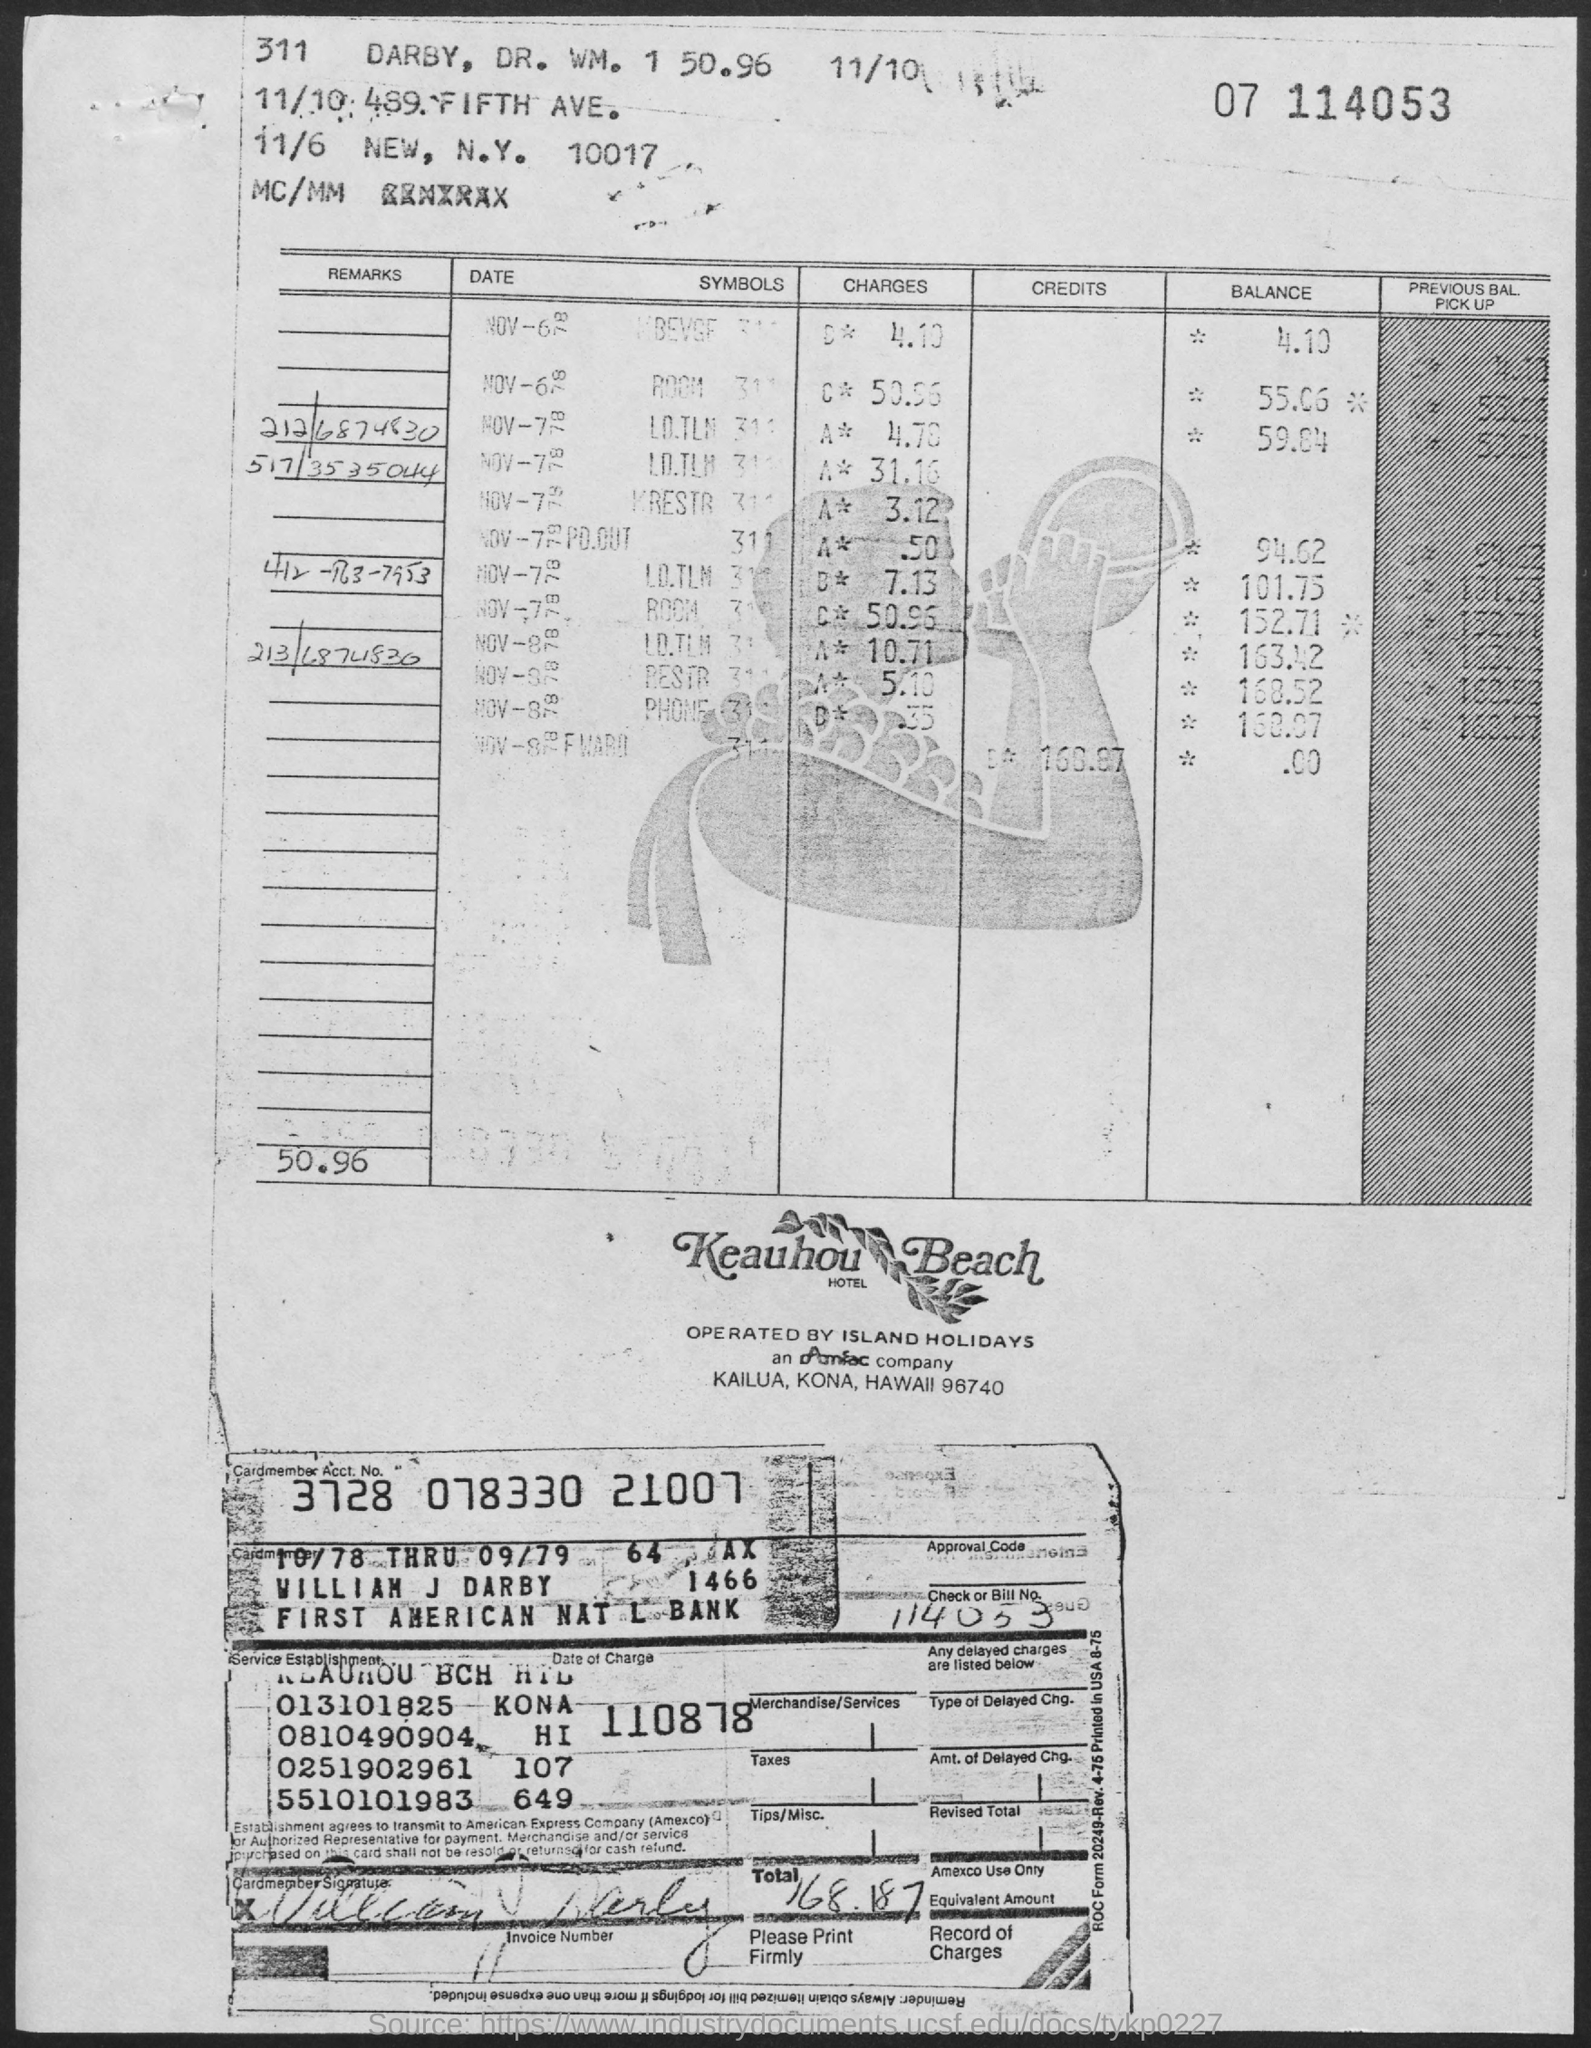What is the Cardmember Account Number?
Provide a succinct answer. 3728 078330 21007. What is the bill number?
Keep it short and to the point. 114053. What is the Total?
Provide a short and direct response. 168.187. 